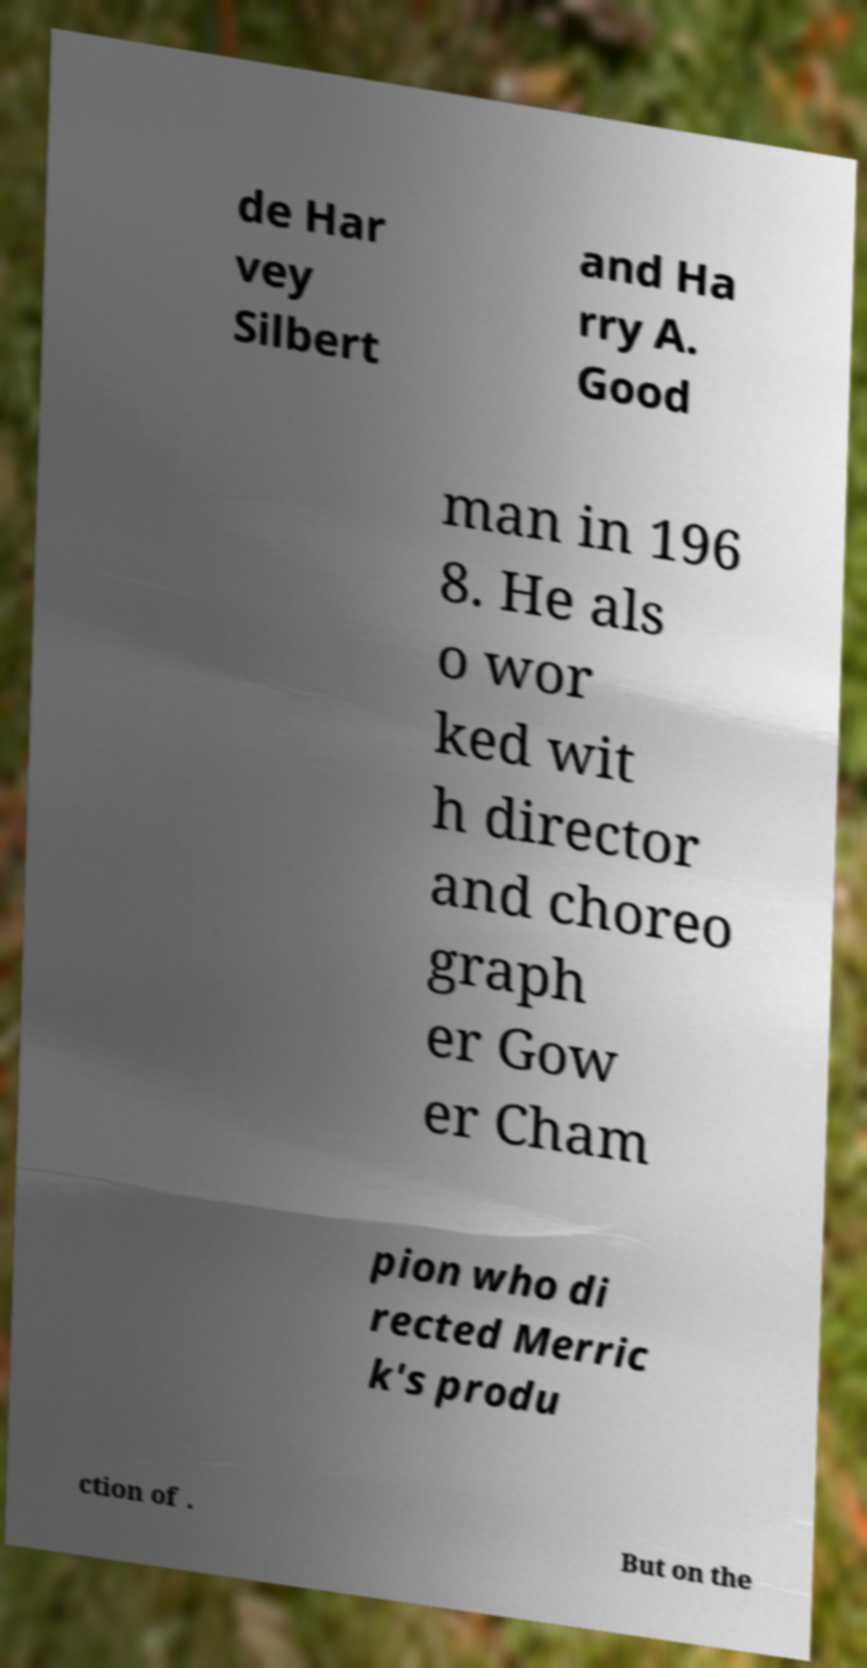Can you accurately transcribe the text from the provided image for me? de Har vey Silbert and Ha rry A. Good man in 196 8. He als o wor ked wit h director and choreo graph er Gow er Cham pion who di rected Merric k's produ ction of . But on the 